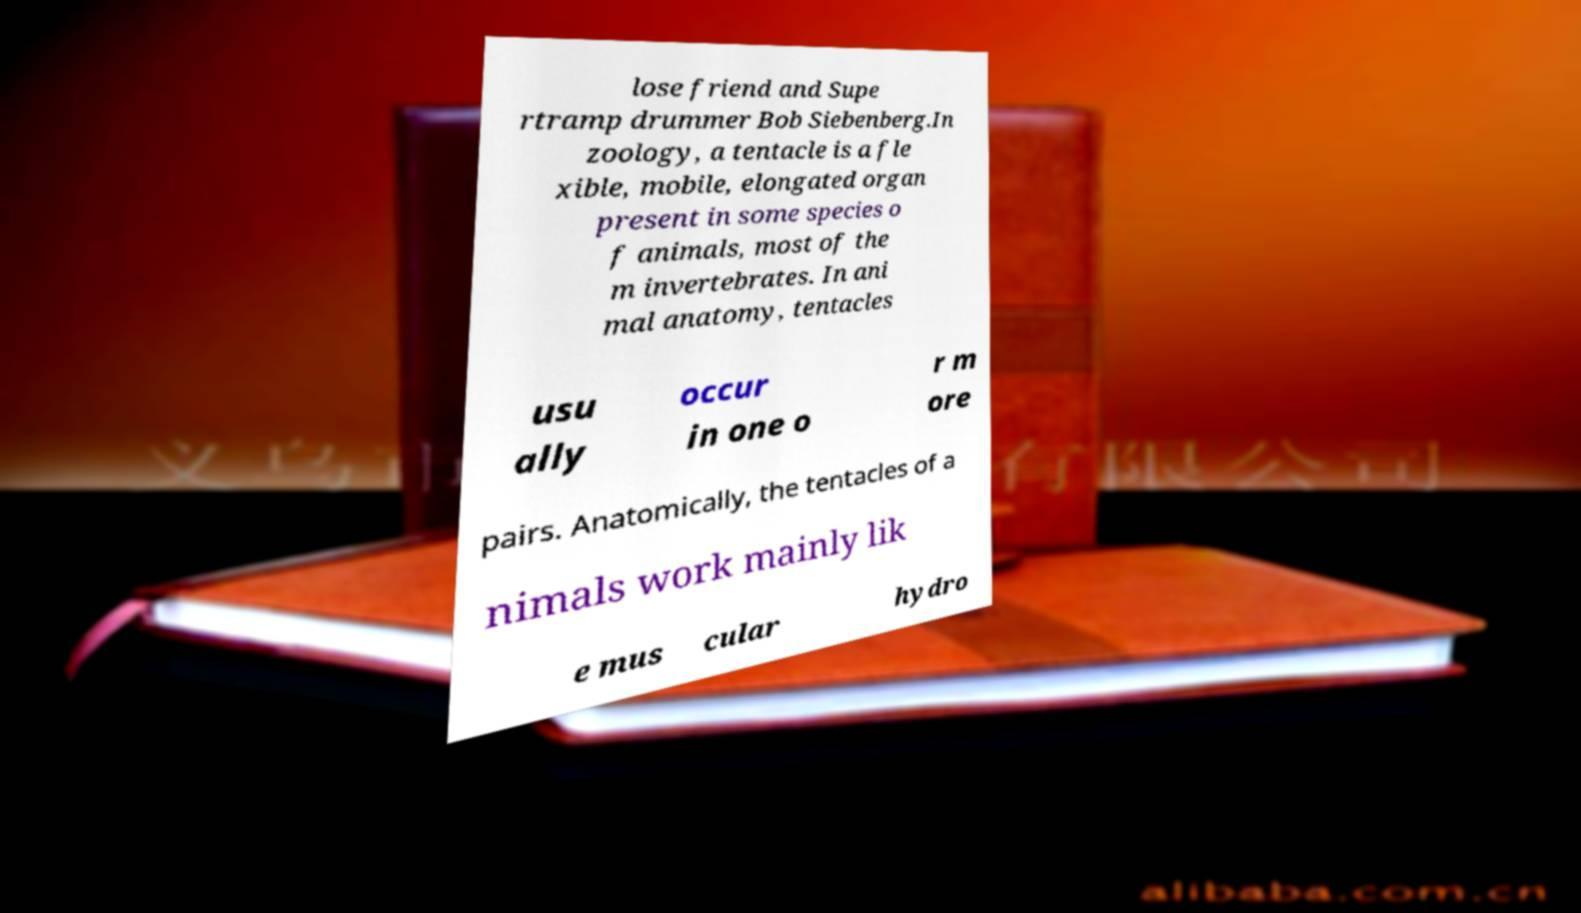Please identify and transcribe the text found in this image. lose friend and Supe rtramp drummer Bob Siebenberg.In zoology, a tentacle is a fle xible, mobile, elongated organ present in some species o f animals, most of the m invertebrates. In ani mal anatomy, tentacles usu ally occur in one o r m ore pairs. Anatomically, the tentacles of a nimals work mainly lik e mus cular hydro 